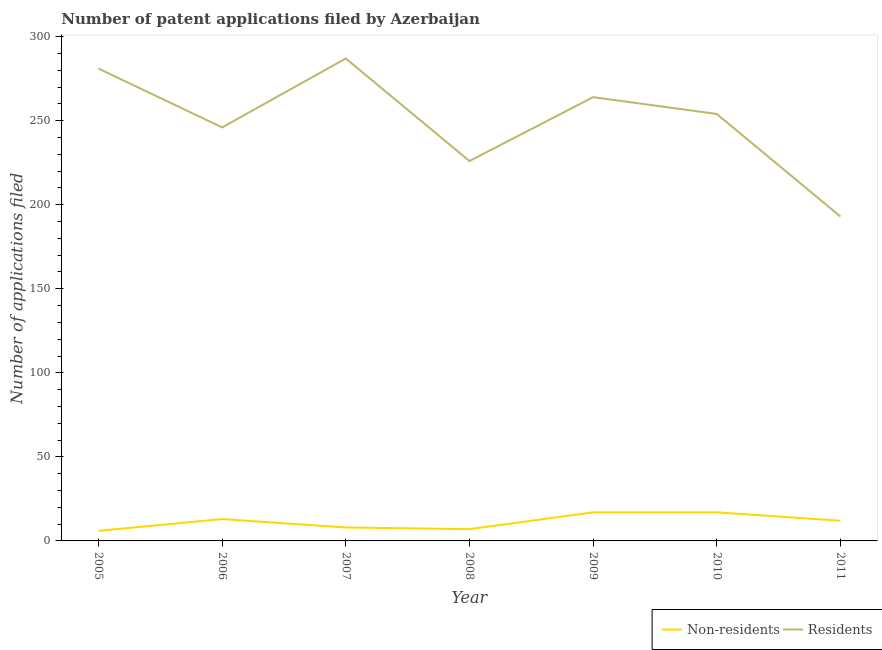Does the line corresponding to number of patent applications by residents intersect with the line corresponding to number of patent applications by non residents?
Offer a very short reply. No. What is the number of patent applications by non residents in 2006?
Offer a very short reply. 13. Across all years, what is the maximum number of patent applications by residents?
Offer a terse response. 287. Across all years, what is the minimum number of patent applications by residents?
Offer a very short reply. 193. In which year was the number of patent applications by residents maximum?
Give a very brief answer. 2007. In which year was the number of patent applications by residents minimum?
Provide a short and direct response. 2011. What is the total number of patent applications by residents in the graph?
Make the answer very short. 1751. What is the difference between the number of patent applications by non residents in 2008 and that in 2011?
Your response must be concise. -5. What is the difference between the number of patent applications by residents in 2008 and the number of patent applications by non residents in 2010?
Your response must be concise. 209. What is the average number of patent applications by non residents per year?
Your answer should be compact. 11.43. In the year 2008, what is the difference between the number of patent applications by non residents and number of patent applications by residents?
Make the answer very short. -219. What is the ratio of the number of patent applications by non residents in 2006 to that in 2008?
Provide a succinct answer. 1.86. Is the number of patent applications by non residents in 2005 less than that in 2006?
Your answer should be very brief. Yes. What is the difference between the highest and the second highest number of patent applications by non residents?
Provide a succinct answer. 0. What is the difference between the highest and the lowest number of patent applications by residents?
Ensure brevity in your answer.  94. Is the sum of the number of patent applications by residents in 2005 and 2011 greater than the maximum number of patent applications by non residents across all years?
Provide a short and direct response. Yes. Is the number of patent applications by non residents strictly less than the number of patent applications by residents over the years?
Your answer should be very brief. Yes. How many lines are there?
Your answer should be compact. 2. How many years are there in the graph?
Your answer should be very brief. 7. What is the difference between two consecutive major ticks on the Y-axis?
Your answer should be compact. 50. Are the values on the major ticks of Y-axis written in scientific E-notation?
Your response must be concise. No. How many legend labels are there?
Your answer should be compact. 2. How are the legend labels stacked?
Keep it short and to the point. Horizontal. What is the title of the graph?
Provide a short and direct response. Number of patent applications filed by Azerbaijan. What is the label or title of the X-axis?
Your answer should be very brief. Year. What is the label or title of the Y-axis?
Offer a terse response. Number of applications filed. What is the Number of applications filed of Residents in 2005?
Make the answer very short. 281. What is the Number of applications filed in Residents in 2006?
Your response must be concise. 246. What is the Number of applications filed in Residents in 2007?
Provide a succinct answer. 287. What is the Number of applications filed of Non-residents in 2008?
Give a very brief answer. 7. What is the Number of applications filed of Residents in 2008?
Offer a terse response. 226. What is the Number of applications filed in Non-residents in 2009?
Keep it short and to the point. 17. What is the Number of applications filed of Residents in 2009?
Provide a succinct answer. 264. What is the Number of applications filed of Non-residents in 2010?
Your answer should be very brief. 17. What is the Number of applications filed of Residents in 2010?
Ensure brevity in your answer.  254. What is the Number of applications filed in Non-residents in 2011?
Offer a terse response. 12. What is the Number of applications filed of Residents in 2011?
Ensure brevity in your answer.  193. Across all years, what is the maximum Number of applications filed in Residents?
Your response must be concise. 287. Across all years, what is the minimum Number of applications filed of Non-residents?
Provide a succinct answer. 6. Across all years, what is the minimum Number of applications filed in Residents?
Your response must be concise. 193. What is the total Number of applications filed in Residents in the graph?
Your answer should be very brief. 1751. What is the difference between the Number of applications filed in Non-residents in 2005 and that in 2006?
Provide a short and direct response. -7. What is the difference between the Number of applications filed in Non-residents in 2005 and that in 2007?
Give a very brief answer. -2. What is the difference between the Number of applications filed in Non-residents in 2005 and that in 2008?
Provide a short and direct response. -1. What is the difference between the Number of applications filed of Residents in 2005 and that in 2008?
Your response must be concise. 55. What is the difference between the Number of applications filed in Residents in 2005 and that in 2009?
Offer a terse response. 17. What is the difference between the Number of applications filed in Residents in 2005 and that in 2011?
Ensure brevity in your answer.  88. What is the difference between the Number of applications filed in Residents in 2006 and that in 2007?
Offer a terse response. -41. What is the difference between the Number of applications filed of Non-residents in 2006 and that in 2008?
Give a very brief answer. 6. What is the difference between the Number of applications filed in Residents in 2006 and that in 2008?
Your answer should be very brief. 20. What is the difference between the Number of applications filed in Non-residents in 2006 and that in 2009?
Offer a terse response. -4. What is the difference between the Number of applications filed in Residents in 2006 and that in 2009?
Provide a succinct answer. -18. What is the difference between the Number of applications filed of Residents in 2006 and that in 2010?
Your response must be concise. -8. What is the difference between the Number of applications filed of Non-residents in 2006 and that in 2011?
Make the answer very short. 1. What is the difference between the Number of applications filed of Residents in 2007 and that in 2008?
Your response must be concise. 61. What is the difference between the Number of applications filed in Non-residents in 2007 and that in 2009?
Give a very brief answer. -9. What is the difference between the Number of applications filed of Non-residents in 2007 and that in 2010?
Ensure brevity in your answer.  -9. What is the difference between the Number of applications filed of Non-residents in 2007 and that in 2011?
Give a very brief answer. -4. What is the difference between the Number of applications filed of Residents in 2007 and that in 2011?
Give a very brief answer. 94. What is the difference between the Number of applications filed in Non-residents in 2008 and that in 2009?
Give a very brief answer. -10. What is the difference between the Number of applications filed of Residents in 2008 and that in 2009?
Provide a short and direct response. -38. What is the difference between the Number of applications filed in Residents in 2008 and that in 2010?
Provide a short and direct response. -28. What is the difference between the Number of applications filed in Non-residents in 2008 and that in 2011?
Make the answer very short. -5. What is the difference between the Number of applications filed of Non-residents in 2009 and that in 2010?
Make the answer very short. 0. What is the difference between the Number of applications filed in Residents in 2009 and that in 2010?
Your response must be concise. 10. What is the difference between the Number of applications filed in Non-residents in 2009 and that in 2011?
Give a very brief answer. 5. What is the difference between the Number of applications filed of Residents in 2009 and that in 2011?
Provide a short and direct response. 71. What is the difference between the Number of applications filed in Non-residents in 2010 and that in 2011?
Your response must be concise. 5. What is the difference between the Number of applications filed of Residents in 2010 and that in 2011?
Your answer should be compact. 61. What is the difference between the Number of applications filed of Non-residents in 2005 and the Number of applications filed of Residents in 2006?
Your response must be concise. -240. What is the difference between the Number of applications filed of Non-residents in 2005 and the Number of applications filed of Residents in 2007?
Your answer should be compact. -281. What is the difference between the Number of applications filed of Non-residents in 2005 and the Number of applications filed of Residents in 2008?
Make the answer very short. -220. What is the difference between the Number of applications filed in Non-residents in 2005 and the Number of applications filed in Residents in 2009?
Ensure brevity in your answer.  -258. What is the difference between the Number of applications filed of Non-residents in 2005 and the Number of applications filed of Residents in 2010?
Offer a very short reply. -248. What is the difference between the Number of applications filed in Non-residents in 2005 and the Number of applications filed in Residents in 2011?
Your response must be concise. -187. What is the difference between the Number of applications filed in Non-residents in 2006 and the Number of applications filed in Residents in 2007?
Offer a very short reply. -274. What is the difference between the Number of applications filed of Non-residents in 2006 and the Number of applications filed of Residents in 2008?
Ensure brevity in your answer.  -213. What is the difference between the Number of applications filed of Non-residents in 2006 and the Number of applications filed of Residents in 2009?
Your answer should be compact. -251. What is the difference between the Number of applications filed in Non-residents in 2006 and the Number of applications filed in Residents in 2010?
Offer a very short reply. -241. What is the difference between the Number of applications filed of Non-residents in 2006 and the Number of applications filed of Residents in 2011?
Your answer should be very brief. -180. What is the difference between the Number of applications filed in Non-residents in 2007 and the Number of applications filed in Residents in 2008?
Keep it short and to the point. -218. What is the difference between the Number of applications filed of Non-residents in 2007 and the Number of applications filed of Residents in 2009?
Your answer should be compact. -256. What is the difference between the Number of applications filed in Non-residents in 2007 and the Number of applications filed in Residents in 2010?
Keep it short and to the point. -246. What is the difference between the Number of applications filed in Non-residents in 2007 and the Number of applications filed in Residents in 2011?
Offer a terse response. -185. What is the difference between the Number of applications filed in Non-residents in 2008 and the Number of applications filed in Residents in 2009?
Provide a succinct answer. -257. What is the difference between the Number of applications filed in Non-residents in 2008 and the Number of applications filed in Residents in 2010?
Provide a succinct answer. -247. What is the difference between the Number of applications filed in Non-residents in 2008 and the Number of applications filed in Residents in 2011?
Give a very brief answer. -186. What is the difference between the Number of applications filed of Non-residents in 2009 and the Number of applications filed of Residents in 2010?
Your answer should be compact. -237. What is the difference between the Number of applications filed in Non-residents in 2009 and the Number of applications filed in Residents in 2011?
Provide a short and direct response. -176. What is the difference between the Number of applications filed of Non-residents in 2010 and the Number of applications filed of Residents in 2011?
Give a very brief answer. -176. What is the average Number of applications filed of Non-residents per year?
Make the answer very short. 11.43. What is the average Number of applications filed in Residents per year?
Ensure brevity in your answer.  250.14. In the year 2005, what is the difference between the Number of applications filed of Non-residents and Number of applications filed of Residents?
Ensure brevity in your answer.  -275. In the year 2006, what is the difference between the Number of applications filed in Non-residents and Number of applications filed in Residents?
Provide a short and direct response. -233. In the year 2007, what is the difference between the Number of applications filed in Non-residents and Number of applications filed in Residents?
Your response must be concise. -279. In the year 2008, what is the difference between the Number of applications filed in Non-residents and Number of applications filed in Residents?
Your answer should be compact. -219. In the year 2009, what is the difference between the Number of applications filed of Non-residents and Number of applications filed of Residents?
Your response must be concise. -247. In the year 2010, what is the difference between the Number of applications filed of Non-residents and Number of applications filed of Residents?
Offer a terse response. -237. In the year 2011, what is the difference between the Number of applications filed in Non-residents and Number of applications filed in Residents?
Your answer should be very brief. -181. What is the ratio of the Number of applications filed of Non-residents in 2005 to that in 2006?
Your response must be concise. 0.46. What is the ratio of the Number of applications filed in Residents in 2005 to that in 2006?
Ensure brevity in your answer.  1.14. What is the ratio of the Number of applications filed of Non-residents in 2005 to that in 2007?
Your answer should be compact. 0.75. What is the ratio of the Number of applications filed in Residents in 2005 to that in 2007?
Give a very brief answer. 0.98. What is the ratio of the Number of applications filed in Residents in 2005 to that in 2008?
Ensure brevity in your answer.  1.24. What is the ratio of the Number of applications filed of Non-residents in 2005 to that in 2009?
Your answer should be very brief. 0.35. What is the ratio of the Number of applications filed of Residents in 2005 to that in 2009?
Offer a terse response. 1.06. What is the ratio of the Number of applications filed in Non-residents in 2005 to that in 2010?
Keep it short and to the point. 0.35. What is the ratio of the Number of applications filed of Residents in 2005 to that in 2010?
Provide a short and direct response. 1.11. What is the ratio of the Number of applications filed in Residents in 2005 to that in 2011?
Your answer should be compact. 1.46. What is the ratio of the Number of applications filed in Non-residents in 2006 to that in 2007?
Offer a terse response. 1.62. What is the ratio of the Number of applications filed of Residents in 2006 to that in 2007?
Your answer should be compact. 0.86. What is the ratio of the Number of applications filed of Non-residents in 2006 to that in 2008?
Offer a very short reply. 1.86. What is the ratio of the Number of applications filed of Residents in 2006 to that in 2008?
Provide a succinct answer. 1.09. What is the ratio of the Number of applications filed in Non-residents in 2006 to that in 2009?
Ensure brevity in your answer.  0.76. What is the ratio of the Number of applications filed of Residents in 2006 to that in 2009?
Make the answer very short. 0.93. What is the ratio of the Number of applications filed in Non-residents in 2006 to that in 2010?
Provide a succinct answer. 0.76. What is the ratio of the Number of applications filed in Residents in 2006 to that in 2010?
Give a very brief answer. 0.97. What is the ratio of the Number of applications filed of Residents in 2006 to that in 2011?
Offer a very short reply. 1.27. What is the ratio of the Number of applications filed in Non-residents in 2007 to that in 2008?
Offer a very short reply. 1.14. What is the ratio of the Number of applications filed of Residents in 2007 to that in 2008?
Your response must be concise. 1.27. What is the ratio of the Number of applications filed in Non-residents in 2007 to that in 2009?
Offer a very short reply. 0.47. What is the ratio of the Number of applications filed of Residents in 2007 to that in 2009?
Ensure brevity in your answer.  1.09. What is the ratio of the Number of applications filed of Non-residents in 2007 to that in 2010?
Provide a short and direct response. 0.47. What is the ratio of the Number of applications filed in Residents in 2007 to that in 2010?
Your answer should be compact. 1.13. What is the ratio of the Number of applications filed of Residents in 2007 to that in 2011?
Your answer should be compact. 1.49. What is the ratio of the Number of applications filed of Non-residents in 2008 to that in 2009?
Provide a short and direct response. 0.41. What is the ratio of the Number of applications filed of Residents in 2008 to that in 2009?
Provide a succinct answer. 0.86. What is the ratio of the Number of applications filed of Non-residents in 2008 to that in 2010?
Your answer should be very brief. 0.41. What is the ratio of the Number of applications filed in Residents in 2008 to that in 2010?
Provide a short and direct response. 0.89. What is the ratio of the Number of applications filed in Non-residents in 2008 to that in 2011?
Provide a short and direct response. 0.58. What is the ratio of the Number of applications filed in Residents in 2008 to that in 2011?
Your answer should be very brief. 1.17. What is the ratio of the Number of applications filed of Non-residents in 2009 to that in 2010?
Give a very brief answer. 1. What is the ratio of the Number of applications filed of Residents in 2009 to that in 2010?
Offer a very short reply. 1.04. What is the ratio of the Number of applications filed in Non-residents in 2009 to that in 2011?
Provide a succinct answer. 1.42. What is the ratio of the Number of applications filed in Residents in 2009 to that in 2011?
Provide a short and direct response. 1.37. What is the ratio of the Number of applications filed in Non-residents in 2010 to that in 2011?
Offer a very short reply. 1.42. What is the ratio of the Number of applications filed in Residents in 2010 to that in 2011?
Ensure brevity in your answer.  1.32. What is the difference between the highest and the second highest Number of applications filed in Non-residents?
Offer a very short reply. 0. What is the difference between the highest and the lowest Number of applications filed in Non-residents?
Make the answer very short. 11. What is the difference between the highest and the lowest Number of applications filed in Residents?
Your answer should be very brief. 94. 